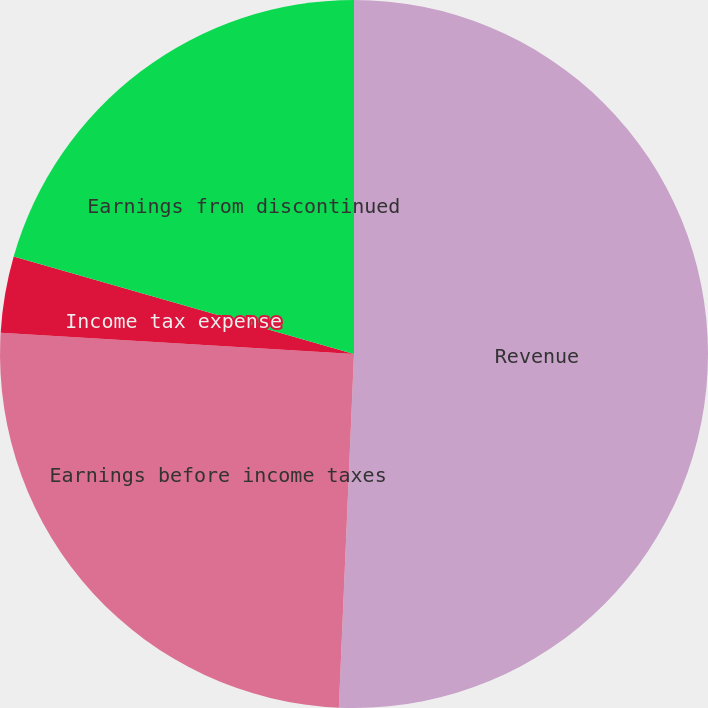Convert chart to OTSL. <chart><loc_0><loc_0><loc_500><loc_500><pie_chart><fcel>Revenue<fcel>Earnings before income taxes<fcel>Income tax expense<fcel>Earnings from discontinued<nl><fcel>50.68%<fcel>25.28%<fcel>3.48%<fcel>20.56%<nl></chart> 